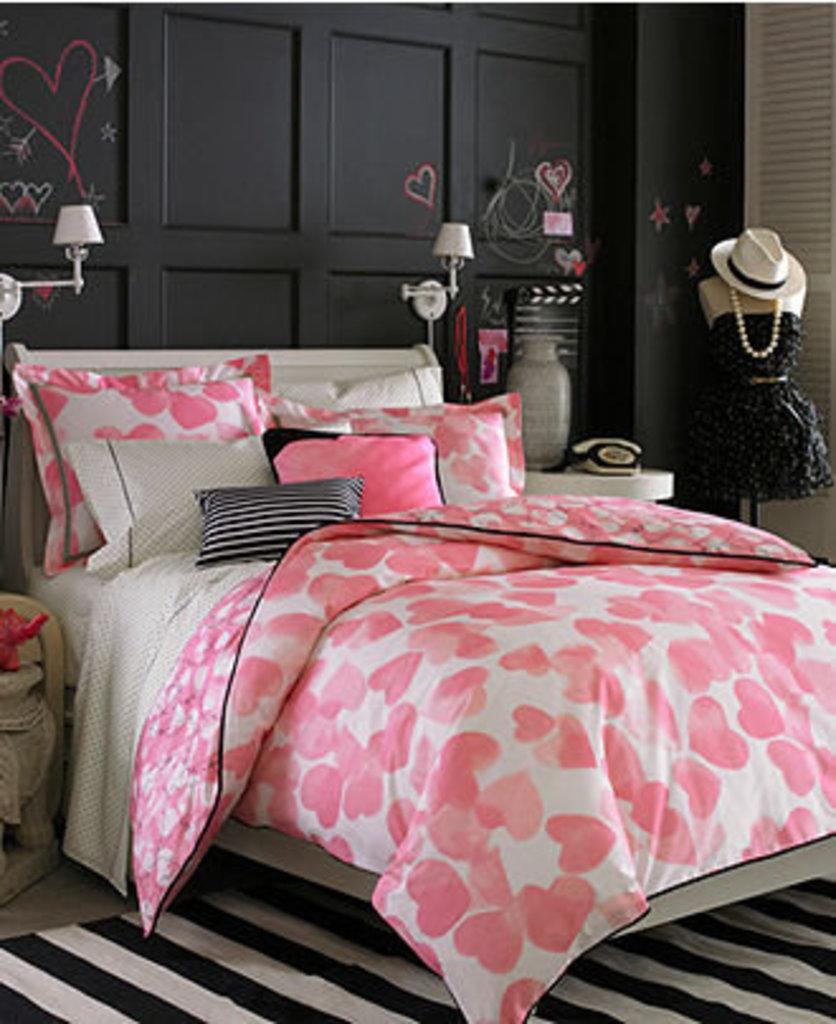Could you give a brief overview of what you see in this image? In this image I can see a bed,blanket,pillow. On the table there is a telephone and a vase. 